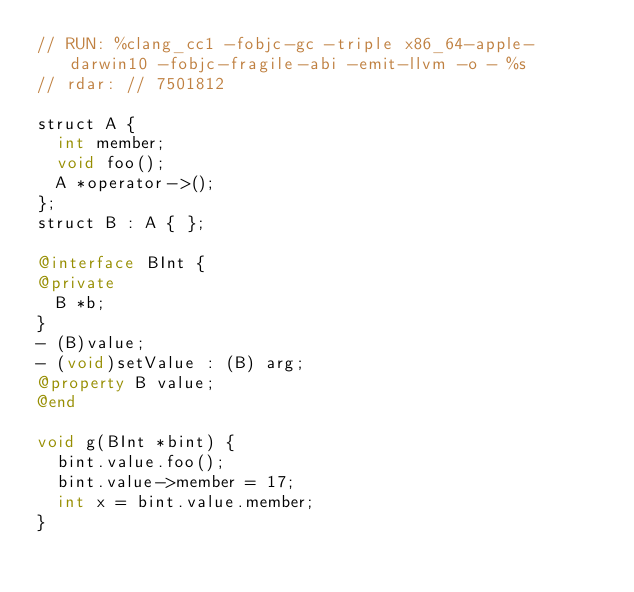Convert code to text. <code><loc_0><loc_0><loc_500><loc_500><_ObjectiveC_>// RUN: %clang_cc1 -fobjc-gc -triple x86_64-apple-darwin10 -fobjc-fragile-abi -emit-llvm -o - %s
// rdar: // 7501812

struct A {
  int member;
  void foo();
  A *operator->();
};
struct B : A { };

@interface BInt {
@private
  B *b;
}
- (B)value;
- (void)setValue : (B) arg;
@property B value;
@end

void g(BInt *bint) {
  bint.value.foo();
  bint.value->member = 17;
  int x = bint.value.member;
}

</code> 